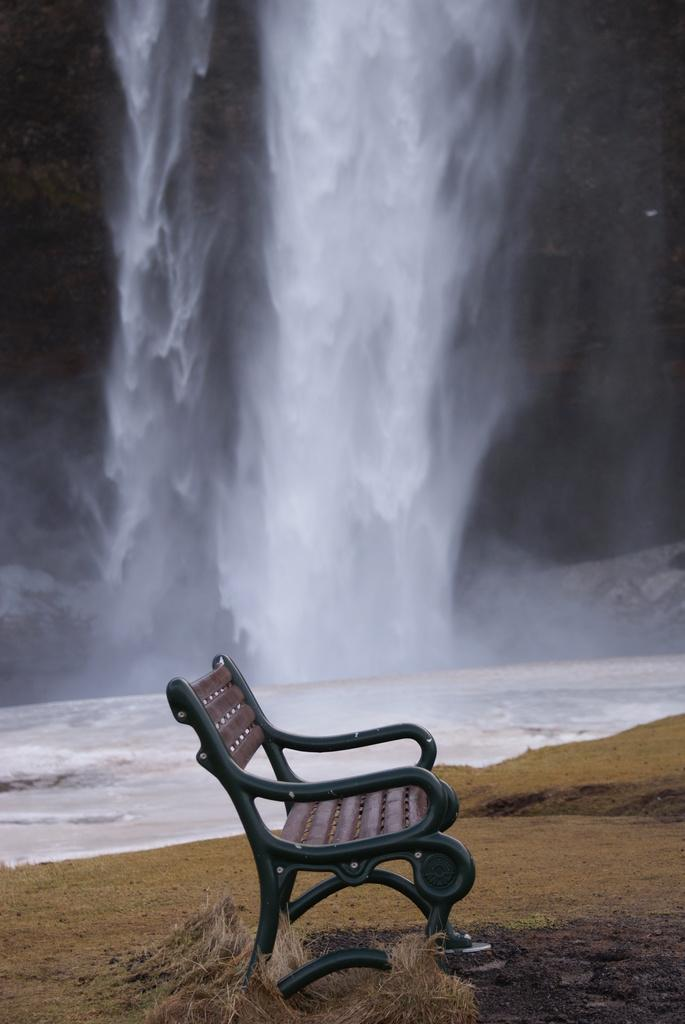What type of seating is present in the image? There is a bench in the image. What type of vegetation can be seen in the image? There is dry grass in the image. What natural feature is visible in the image? There is water visible in the image. What specific water feature can be seen in the image? There are waterfalls in the image. How would you describe the lighting in the image? The background of the image is slightly dark. What type of protest is taking place near the waterfalls in the image? There is no protest present in the image; it features a bench, dry grass, waterfalls, and a slightly dark background. How many frogs can be seen hopping around the waterfalls in the image? There are no frogs present in the image; it features a bench, dry grass, waterfalls, and a slightly dark background. 